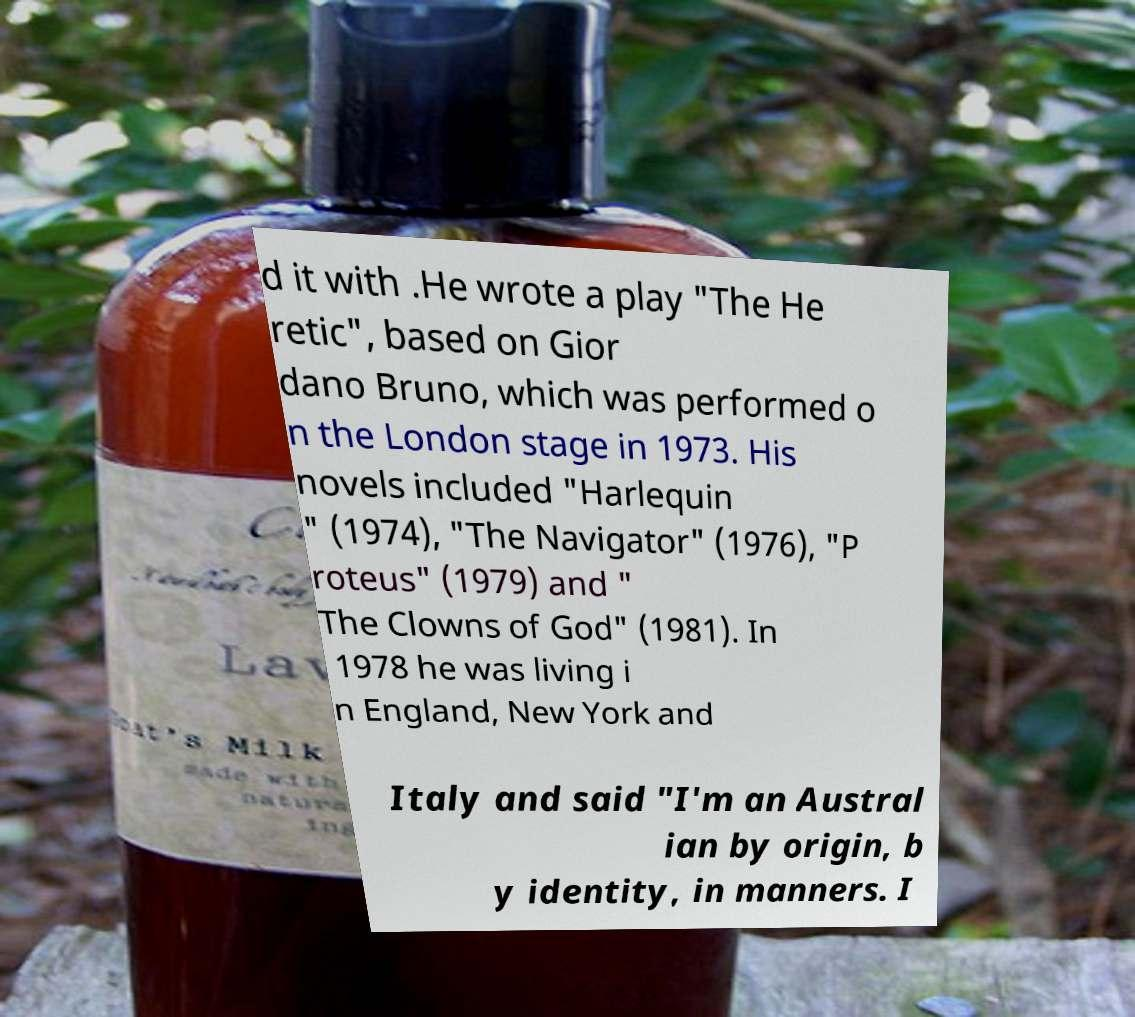What messages or text are displayed in this image? I need them in a readable, typed format. d it with .He wrote a play "The He retic", based on Gior dano Bruno, which was performed o n the London stage in 1973. His novels included "Harlequin " (1974), "The Navigator" (1976), "P roteus" (1979) and " The Clowns of God" (1981). In 1978 he was living i n England, New York and Italy and said "I'm an Austral ian by origin, b y identity, in manners. I 